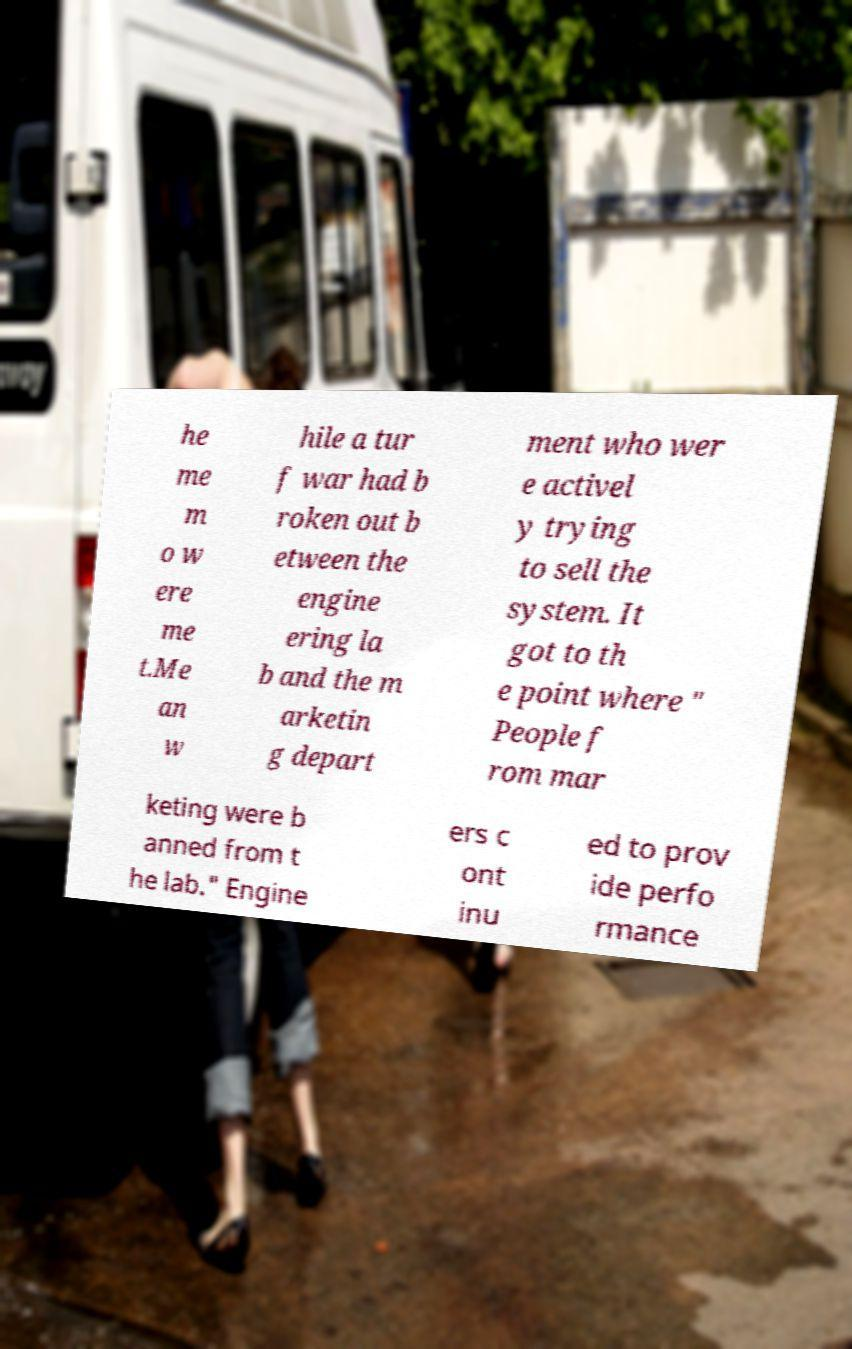There's text embedded in this image that I need extracted. Can you transcribe it verbatim? he me m o w ere me t.Me an w hile a tur f war had b roken out b etween the engine ering la b and the m arketin g depart ment who wer e activel y trying to sell the system. It got to th e point where " People f rom mar keting were b anned from t he lab." Engine ers c ont inu ed to prov ide perfo rmance 